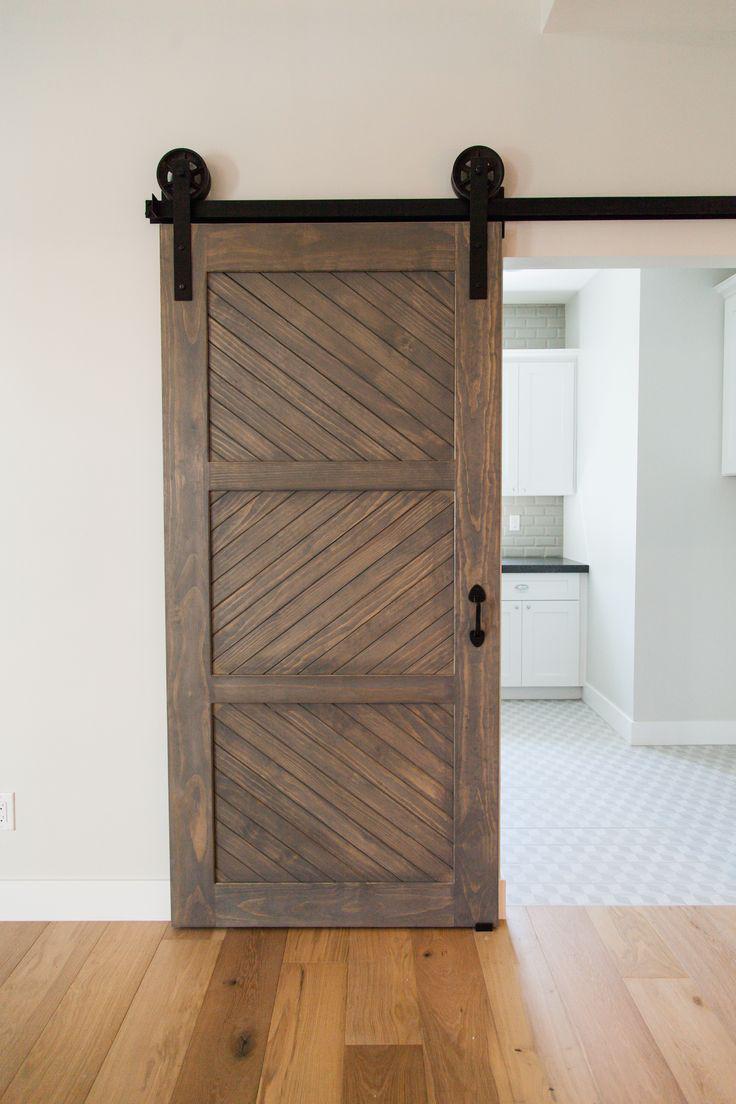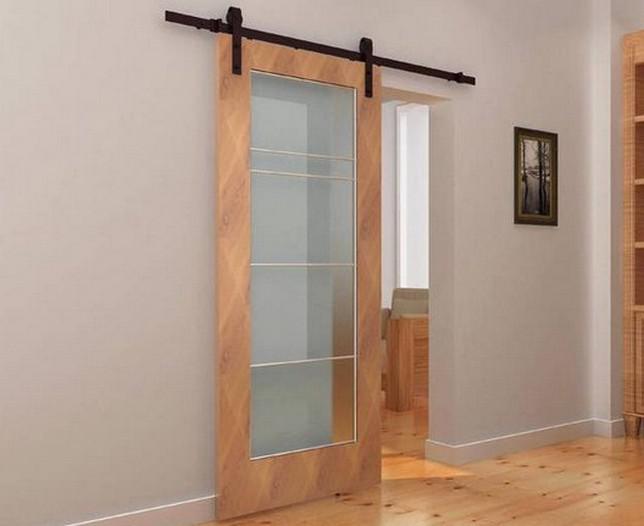The first image is the image on the left, the second image is the image on the right. For the images shown, is this caption "The right image shows a sliding door to the left of the dooorway." true? Answer yes or no. Yes. The first image is the image on the left, the second image is the image on the right. Evaluate the accuracy of this statement regarding the images: "The left and right image contains the same number of hanging doors made of solid wood.". Is it true? Answer yes or no. No. 